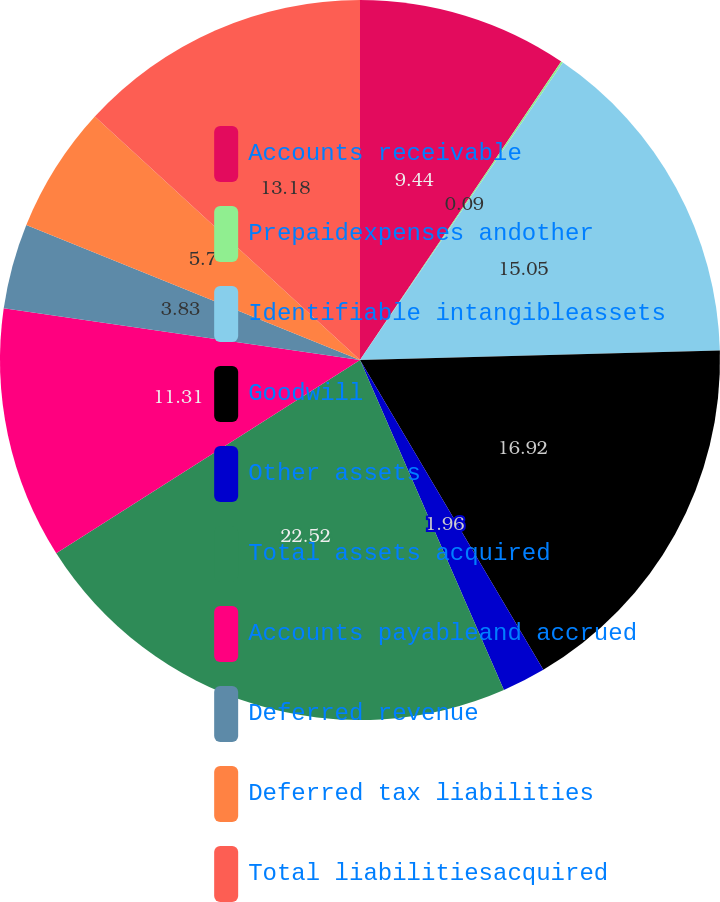<chart> <loc_0><loc_0><loc_500><loc_500><pie_chart><fcel>Accounts receivable<fcel>Prepaidexpenses andother<fcel>Identifiable intangibleassets<fcel>Goodwill<fcel>Other assets<fcel>Total assets acquired<fcel>Accounts payableand accrued<fcel>Deferred revenue<fcel>Deferred tax liabilities<fcel>Total liabilitiesacquired<nl><fcel>9.44%<fcel>0.09%<fcel>15.05%<fcel>16.92%<fcel>1.96%<fcel>22.53%<fcel>11.31%<fcel>3.83%<fcel>5.7%<fcel>13.18%<nl></chart> 